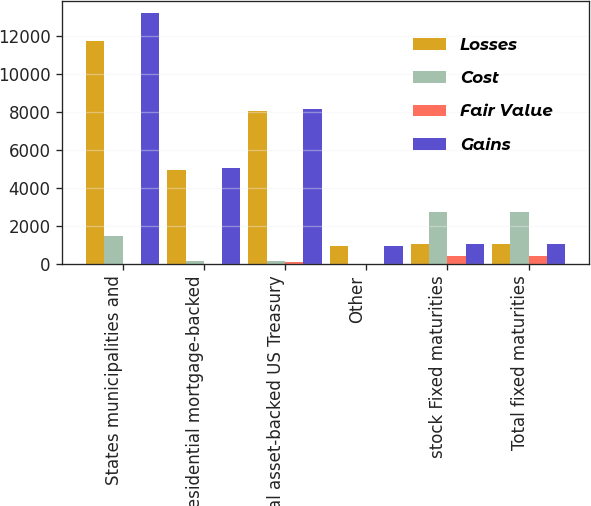<chart> <loc_0><loc_0><loc_500><loc_500><stacked_bar_chart><ecel><fcel>States municipalities and<fcel>Residential mortgage-backed<fcel>Total asset-backed US Treasury<fcel>Other<fcel>stock Fixed maturities<fcel>Total fixed maturities<nl><fcel>Losses<fcel>11729<fcel>4935<fcel>8042<fcel>923<fcel>1068<fcel>1068<nl><fcel>Cost<fcel>1453<fcel>154<fcel>176<fcel>6<fcel>2707<fcel>2707<nl><fcel>Fair Value<fcel>8<fcel>17<fcel>80<fcel>8<fcel>393<fcel>413<nl><fcel>Gains<fcel>13174<fcel>5072<fcel>8138<fcel>921<fcel>1068<fcel>1068<nl></chart> 